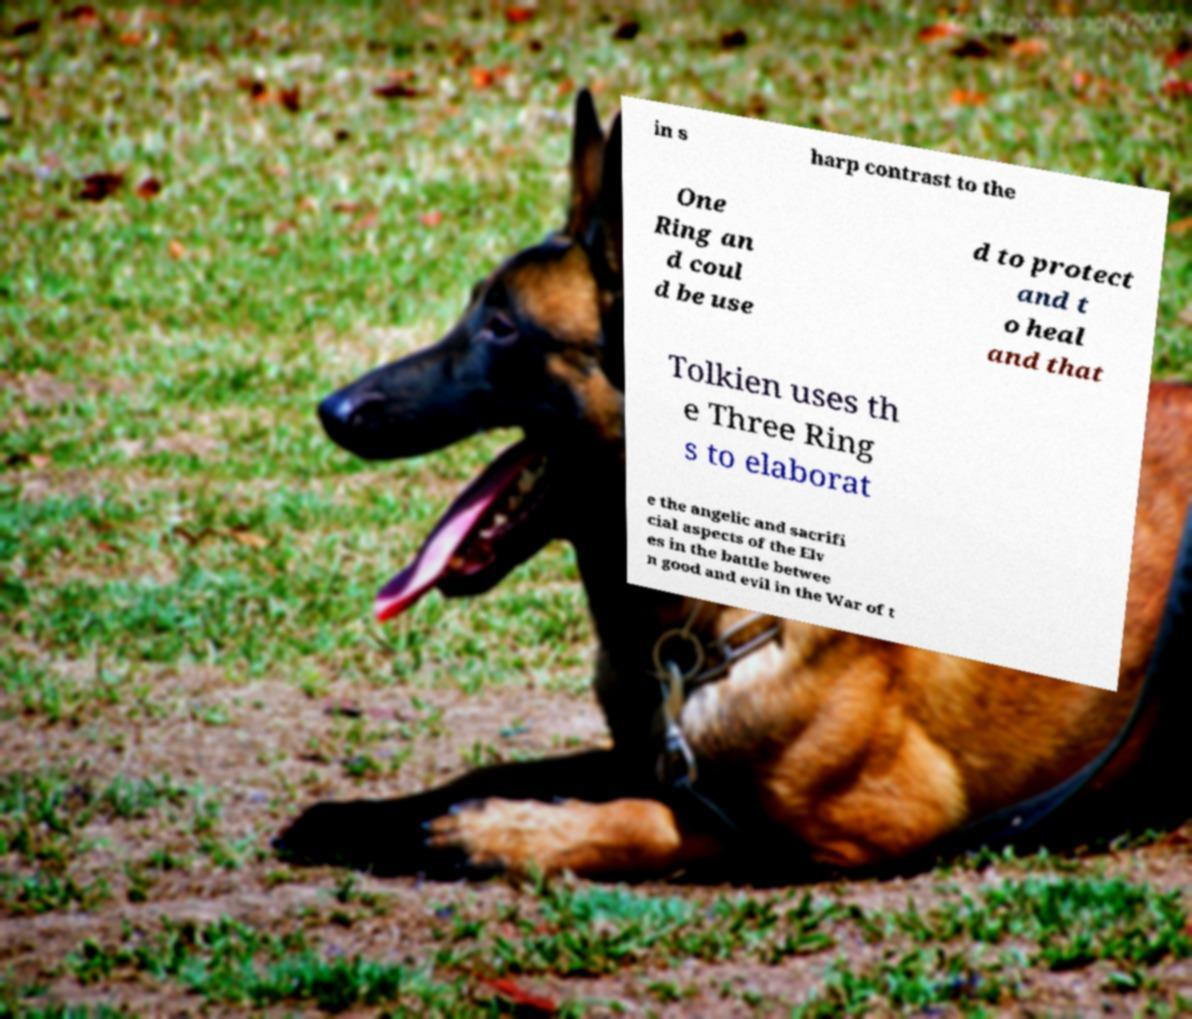I need the written content from this picture converted into text. Can you do that? in s harp contrast to the One Ring an d coul d be use d to protect and t o heal and that Tolkien uses th e Three Ring s to elaborat e the angelic and sacrifi cial aspects of the Elv es in the battle betwee n good and evil in the War of t 